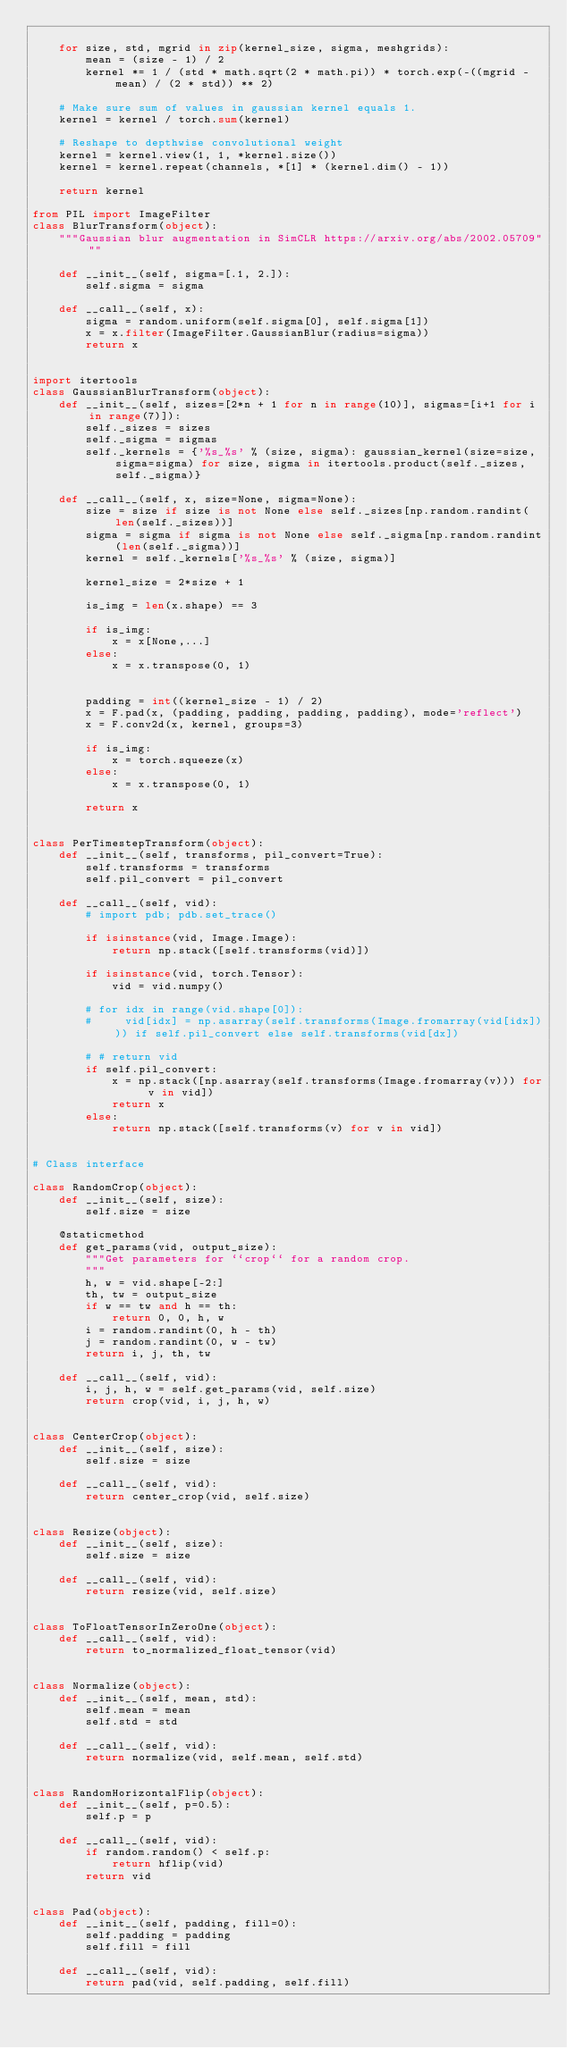<code> <loc_0><loc_0><loc_500><loc_500><_Python_>    
    for size, std, mgrid in zip(kernel_size, sigma, meshgrids):
        mean = (size - 1) / 2
        kernel *= 1 / (std * math.sqrt(2 * math.pi)) * torch.exp(-((mgrid - mean) / (2 * std)) ** 2)

    # Make sure sum of values in gaussian kernel equals 1.
    kernel = kernel / torch.sum(kernel)

    # Reshape to depthwise convolutional weight
    kernel = kernel.view(1, 1, *kernel.size())
    kernel = kernel.repeat(channels, *[1] * (kernel.dim() - 1))

    return kernel

from PIL import ImageFilter
class BlurTransform(object):
    """Gaussian blur augmentation in SimCLR https://arxiv.org/abs/2002.05709"""

    def __init__(self, sigma=[.1, 2.]):
        self.sigma = sigma

    def __call__(self, x):
        sigma = random.uniform(self.sigma[0], self.sigma[1])
        x = x.filter(ImageFilter.GaussianBlur(radius=sigma))
        return x


import itertools
class GaussianBlurTransform(object):
    def __init__(self, sizes=[2*n + 1 for n in range(10)], sigmas=[i+1 for i in range(7)]):
        self._sizes = sizes
        self._sigma = sigmas
        self._kernels = {'%s_%s' % (size, sigma): gaussian_kernel(size=size, sigma=sigma) for size, sigma in itertools.product(self._sizes, self._sigma)}

    def __call__(self, x, size=None, sigma=None):
        size = size if size is not None else self._sizes[np.random.randint(len(self._sizes))]
        sigma = sigma if sigma is not None else self._sigma[np.random.randint(len(self._sigma))]
        kernel = self._kernels['%s_%s' % (size, sigma)]

        kernel_size = 2*size + 1

        is_img = len(x.shape) == 3

        if is_img:
            x = x[None,...]
        else:
            x = x.transpose(0, 1)
            
    
        padding = int((kernel_size - 1) / 2)
        x = F.pad(x, (padding, padding, padding, padding), mode='reflect')
        x = F.conv2d(x, kernel, groups=3)

        if is_img:
            x = torch.squeeze(x)
        else:
            x = x.transpose(0, 1)
    
        return x


class PerTimestepTransform(object):
    def __init__(self, transforms, pil_convert=True):
        self.transforms = transforms
        self.pil_convert = pil_convert

    def __call__(self, vid):
        # import pdb; pdb.set_trace()

        if isinstance(vid, Image.Image):
            return np.stack([self.transforms(vid)])
        
        if isinstance(vid, torch.Tensor):
            vid = vid.numpy()

        # for idx in range(vid.shape[0]):
        #     vid[idx] = np.asarray(self.transforms(Image.fromarray(vid[idx]))) if self.pil_convert else self.transforms(vid[dx])
        
        # # return vid
        if self.pil_convert:
            x = np.stack([np.asarray(self.transforms(Image.fromarray(v))) for v in vid])
            return x
        else:
            return np.stack([self.transforms(v) for v in vid])
    

# Class interface

class RandomCrop(object):
    def __init__(self, size):
        self.size = size

    @staticmethod
    def get_params(vid, output_size):
        """Get parameters for ``crop`` for a random crop.
        """
        h, w = vid.shape[-2:]
        th, tw = output_size
        if w == tw and h == th:
            return 0, 0, h, w
        i = random.randint(0, h - th)
        j = random.randint(0, w - tw)
        return i, j, th, tw

    def __call__(self, vid):
        i, j, h, w = self.get_params(vid, self.size)
        return crop(vid, i, j, h, w)


class CenterCrop(object):
    def __init__(self, size):
        self.size = size

    def __call__(self, vid):
        return center_crop(vid, self.size)


class Resize(object):
    def __init__(self, size):
        self.size = size

    def __call__(self, vid):
        return resize(vid, self.size)


class ToFloatTensorInZeroOne(object):
    def __call__(self, vid):
        return to_normalized_float_tensor(vid)


class Normalize(object):
    def __init__(self, mean, std):
        self.mean = mean
        self.std = std

    def __call__(self, vid):
        return normalize(vid, self.mean, self.std)


class RandomHorizontalFlip(object):
    def __init__(self, p=0.5):
        self.p = p

    def __call__(self, vid):
        if random.random() < self.p:
            return hflip(vid)
        return vid


class Pad(object):
    def __init__(self, padding, fill=0):
        self.padding = padding
        self.fill = fill

    def __call__(self, vid):
        return pad(vid, self.padding, self.fill)
</code> 